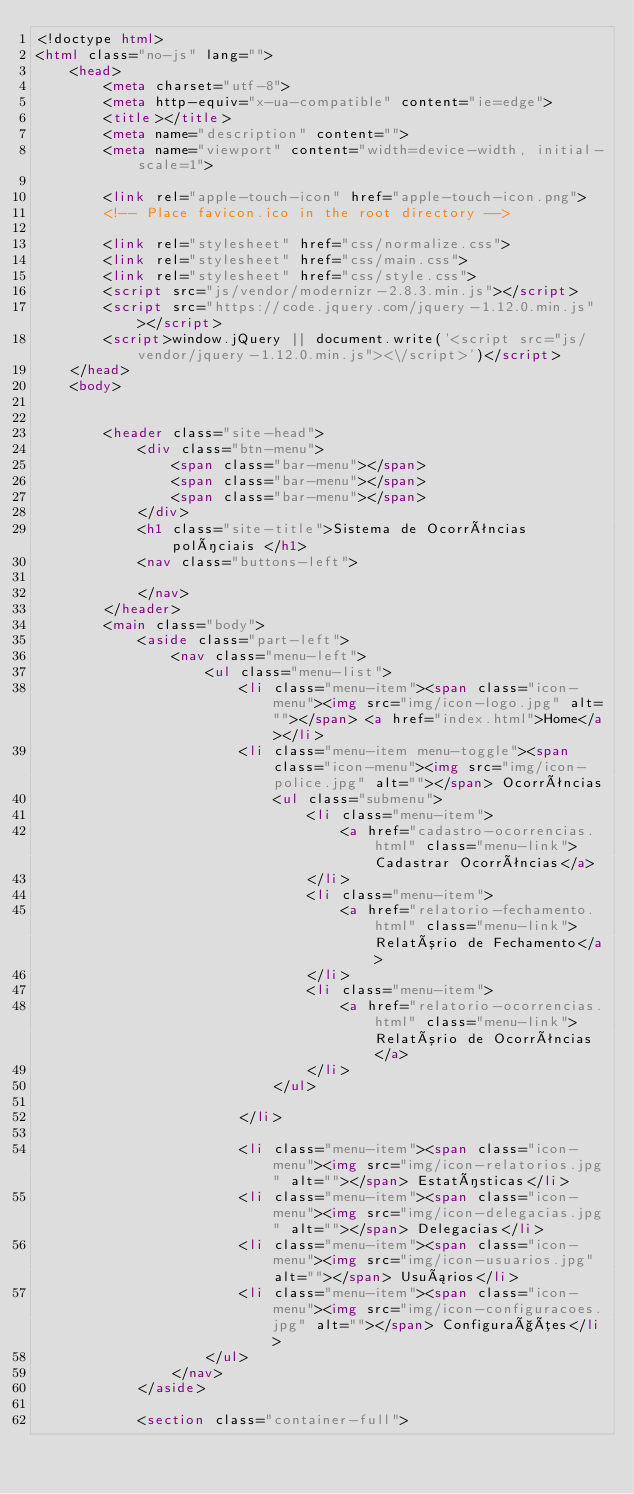Convert code to text. <code><loc_0><loc_0><loc_500><loc_500><_HTML_><!doctype html>
<html class="no-js" lang="">
    <head>
        <meta charset="utf-8">
        <meta http-equiv="x-ua-compatible" content="ie=edge">
        <title></title>
        <meta name="description" content="">
        <meta name="viewport" content="width=device-width, initial-scale=1">

        <link rel="apple-touch-icon" href="apple-touch-icon.png">
        <!-- Place favicon.ico in the root directory -->

        <link rel="stylesheet" href="css/normalize.css">
        <link rel="stylesheet" href="css/main.css">
        <link rel="stylesheet" href="css/style.css">
        <script src="js/vendor/modernizr-2.8.3.min.js"></script>
        <script src="https://code.jquery.com/jquery-1.12.0.min.js"></script>
        <script>window.jQuery || document.write('<script src="js/vendor/jquery-1.12.0.min.js"><\/script>')</script>
    </head>
    <body>


        <header class="site-head">
            <div class="btn-menu">
                <span class="bar-menu"></span>
                <span class="bar-menu"></span>
                <span class="bar-menu"></span>
            </div>
            <h1 class="site-title">Sistema de Ocorrências políciais </h1>
            <nav class="buttons-left">

            </nav>
        </header>
        <main class="body">
            <aside class="part-left">
                <nav class="menu-left">
                    <ul class="menu-list">
                        <li class="menu-item"><span class="icon-menu"><img src="img/icon-logo.jpg" alt=""></span> <a href="index.html">Home</a></li>
                        <li class="menu-item menu-toggle"><span class="icon-menu"><img src="img/icon-police.jpg" alt=""></span> Ocorrências
                            <ul class="submenu">
                                <li class="menu-item">
                                    <a href="cadastro-ocorrencias.html" class="menu-link">Cadastrar Ocorrências</a>
                                </li>
                                <li class="menu-item">
                                    <a href="relatorio-fechamento.html" class="menu-link">Relatório de Fechamento</a>
                                </li>
                                <li class="menu-item">
                                    <a href="relatorio-ocorrencias.html" class="menu-link">Relatório de Ocorrências</a>
                                </li>
                            </ul>

                        </li>

                        <li class="menu-item"><span class="icon-menu"><img src="img/icon-relatorios.jpg" alt=""></span> Estatísticas</li>
                        <li class="menu-item"><span class="icon-menu"><img src="img/icon-delegacias.jpg" alt=""></span> Delegacias</li>
                        <li class="menu-item"><span class="icon-menu"><img src="img/icon-usuarios.jpg" alt=""></span> Usuários</li>
                        <li class="menu-item"><span class="icon-menu"><img src="img/icon-configuracoes.jpg" alt=""></span> Configurações</li>
                    </ul>
                </nav>
            </aside>

            <section class="container-full"></code> 